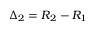Convert formula to latex. <formula><loc_0><loc_0><loc_500><loc_500>\Delta _ { 2 } = R _ { 2 } - R _ { 1 }</formula> 